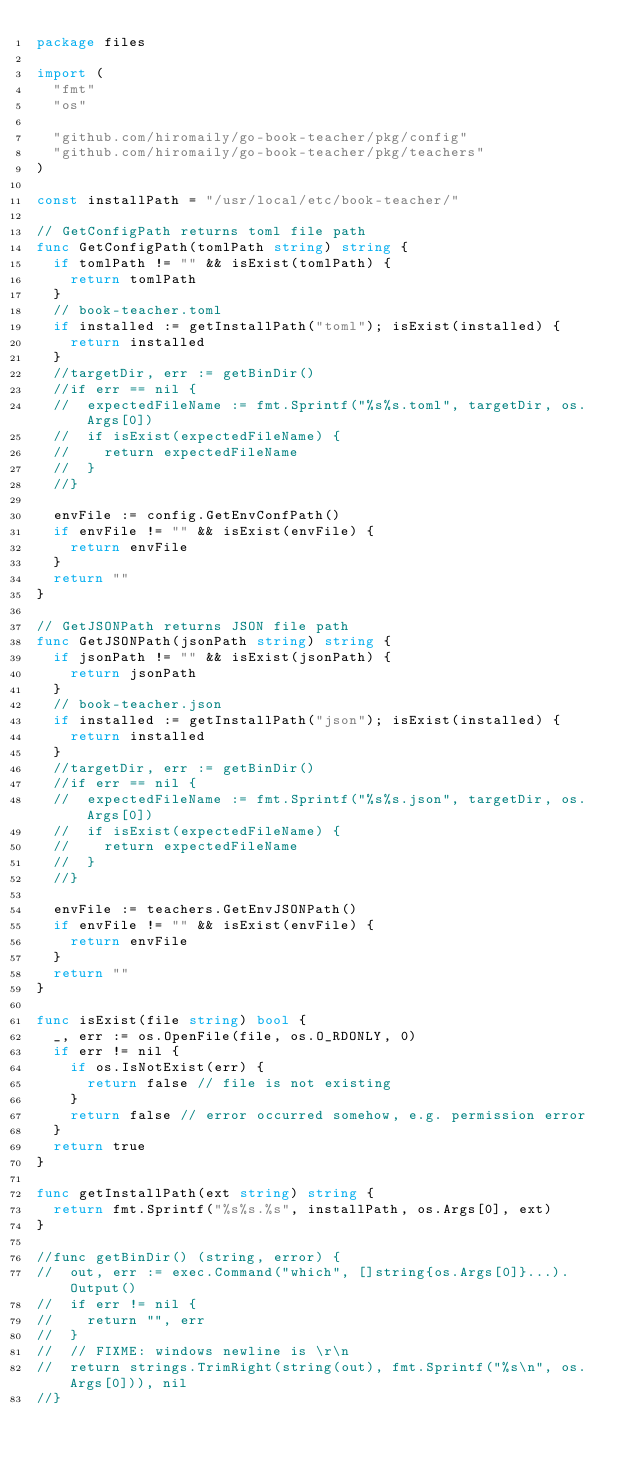<code> <loc_0><loc_0><loc_500><loc_500><_Go_>package files

import (
	"fmt"
	"os"

	"github.com/hiromaily/go-book-teacher/pkg/config"
	"github.com/hiromaily/go-book-teacher/pkg/teachers"
)

const installPath = "/usr/local/etc/book-teacher/"

// GetConfigPath returns toml file path
func GetConfigPath(tomlPath string) string {
	if tomlPath != "" && isExist(tomlPath) {
		return tomlPath
	}
	// book-teacher.toml
	if installed := getInstallPath("toml"); isExist(installed) {
		return installed
	}
	//targetDir, err := getBinDir()
	//if err == nil {
	//	expectedFileName := fmt.Sprintf("%s%s.toml", targetDir, os.Args[0])
	//	if isExist(expectedFileName) {
	//		return expectedFileName
	//	}
	//}

	envFile := config.GetEnvConfPath()
	if envFile != "" && isExist(envFile) {
		return envFile
	}
	return ""
}

// GetJSONPath returns JSON file path
func GetJSONPath(jsonPath string) string {
	if jsonPath != "" && isExist(jsonPath) {
		return jsonPath
	}
	// book-teacher.json
	if installed := getInstallPath("json"); isExist(installed) {
		return installed
	}
	//targetDir, err := getBinDir()
	//if err == nil {
	//	expectedFileName := fmt.Sprintf("%s%s.json", targetDir, os.Args[0])
	//	if isExist(expectedFileName) {
	//		return expectedFileName
	//	}
	//}

	envFile := teachers.GetEnvJSONPath()
	if envFile != "" && isExist(envFile) {
		return envFile
	}
	return ""
}

func isExist(file string) bool {
	_, err := os.OpenFile(file, os.O_RDONLY, 0)
	if err != nil {
		if os.IsNotExist(err) {
			return false // file is not existing
		}
		return false // error occurred somehow, e.g. permission error
	}
	return true
}

func getInstallPath(ext string) string {
	return fmt.Sprintf("%s%s.%s", installPath, os.Args[0], ext)
}

//func getBinDir() (string, error) {
//	out, err := exec.Command("which", []string{os.Args[0]}...).Output()
//	if err != nil {
//		return "", err
//	}
//	// FIXME: windows newline is \r\n
//	return strings.TrimRight(string(out), fmt.Sprintf("%s\n", os.Args[0])), nil
//}
</code> 